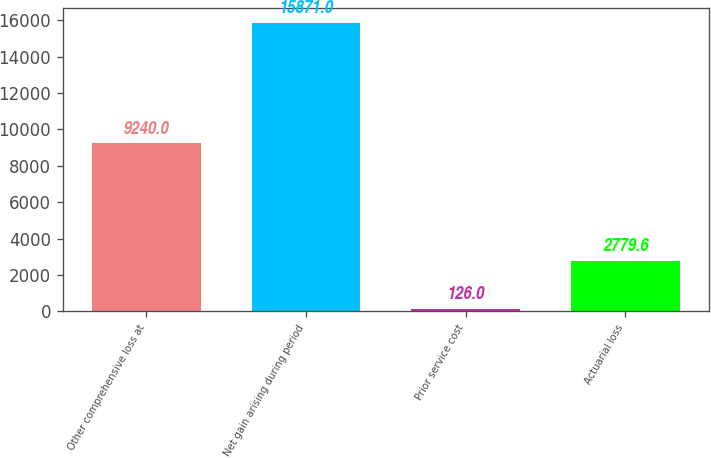Convert chart to OTSL. <chart><loc_0><loc_0><loc_500><loc_500><bar_chart><fcel>Other comprehensive loss at<fcel>Net gain arising during period<fcel>Prior service cost<fcel>Actuarial loss<nl><fcel>9240<fcel>15871<fcel>126<fcel>2779.6<nl></chart> 